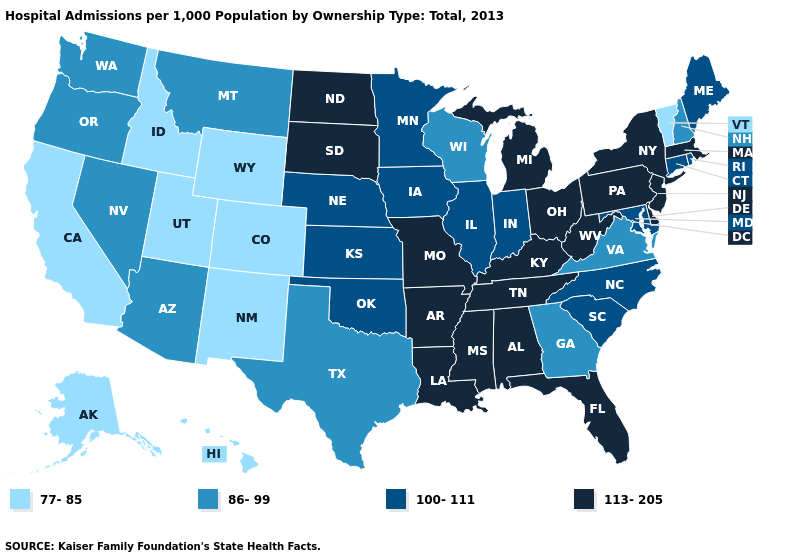What is the lowest value in the South?
Quick response, please. 86-99. How many symbols are there in the legend?
Write a very short answer. 4. What is the lowest value in the West?
Be succinct. 77-85. What is the highest value in the USA?
Concise answer only. 113-205. What is the value of Montana?
Concise answer only. 86-99. What is the highest value in the USA?
Write a very short answer. 113-205. Does Georgia have the lowest value in the South?
Write a very short answer. Yes. Among the states that border Michigan , which have the highest value?
Give a very brief answer. Ohio. What is the value of Washington?
Short answer required. 86-99. What is the value of Alaska?
Quick response, please. 77-85. Which states have the lowest value in the USA?
Short answer required. Alaska, California, Colorado, Hawaii, Idaho, New Mexico, Utah, Vermont, Wyoming. Does Tennessee have the same value as New York?
Give a very brief answer. Yes. Name the states that have a value in the range 86-99?
Answer briefly. Arizona, Georgia, Montana, Nevada, New Hampshire, Oregon, Texas, Virginia, Washington, Wisconsin. Among the states that border Minnesota , which have the highest value?
Give a very brief answer. North Dakota, South Dakota. Does Connecticut have a higher value than Utah?
Quick response, please. Yes. 